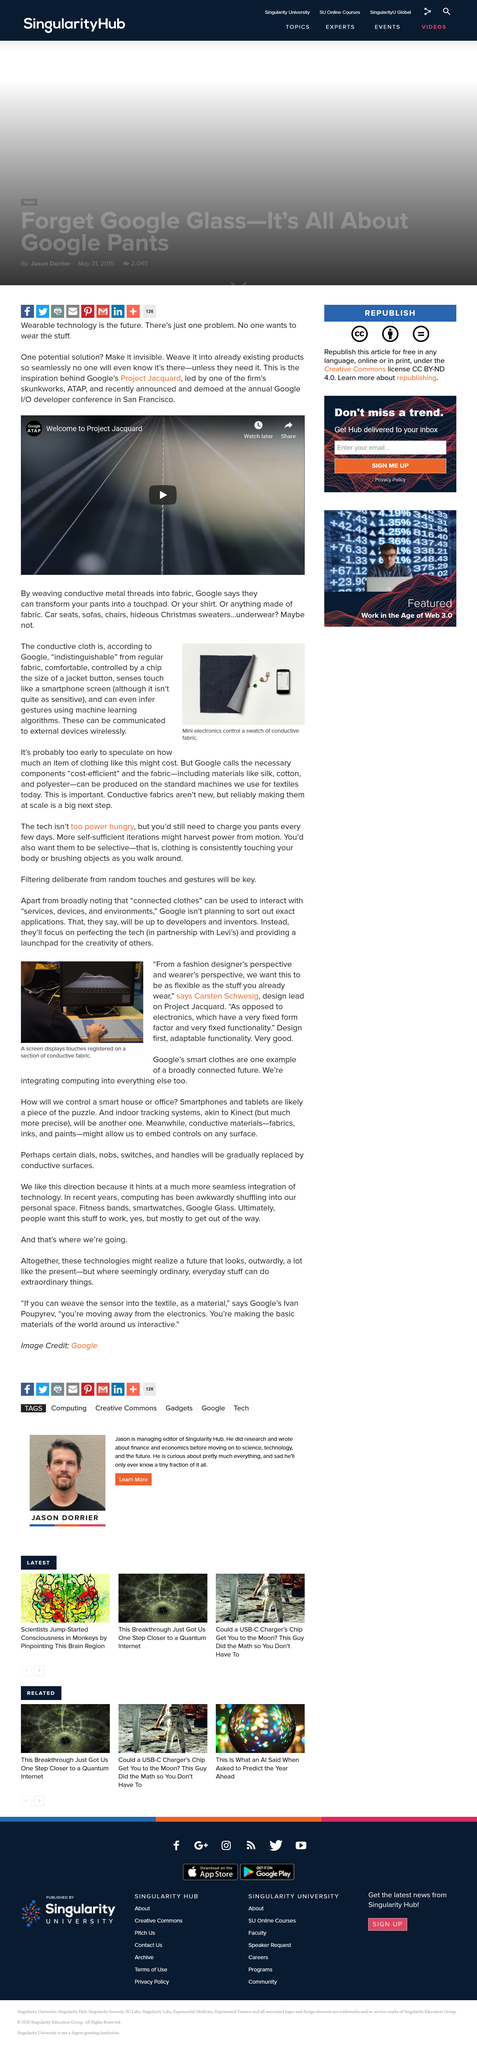Give some essential details in this illustration. The touch screen displays the number of touches registered on a section of conductive fabric. It is currently unknown how much the conductive cloth costs, but Google has deemed the necessary components as cost-efficient. This text describes the use of mini electronics that can be controlled using a swatch of conductive fabric. The user interacts with connected clothes through touch. The conductive cloth is able to sense touch and gestures through the use of machine learning algorithms, like a smartphone screen, but with a sensitivity that is not as high and can only infer gestures. 